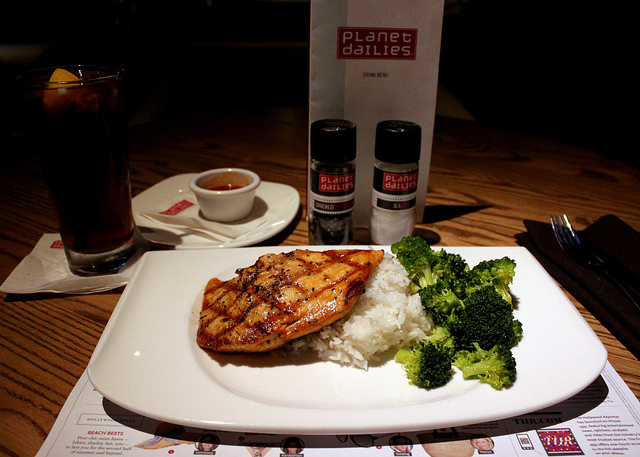Extract all visible text content from this image. dailies Planned Planned daILIES daILIES 